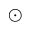<formula> <loc_0><loc_0><loc_500><loc_500>\odot</formula> 